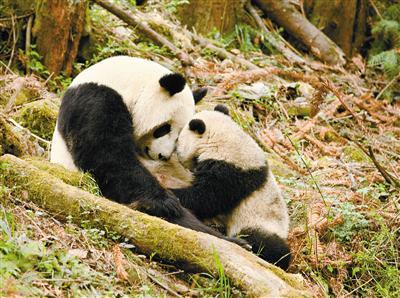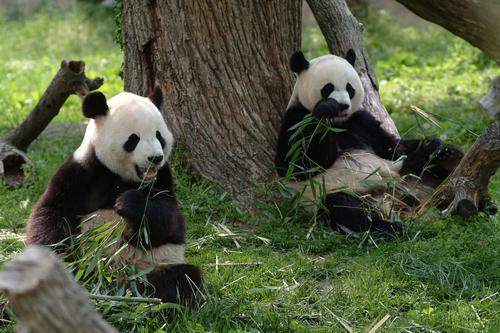The first image is the image on the left, the second image is the image on the right. Given the left and right images, does the statement "Two pandas are sitting to eat in at least one of the images." hold true? Answer yes or no. Yes. The first image is the image on the left, the second image is the image on the right. Analyze the images presented: Is the assertion "An image contains a single panda bear, which lies on its back with at least two paws off the ground." valid? Answer yes or no. No. 